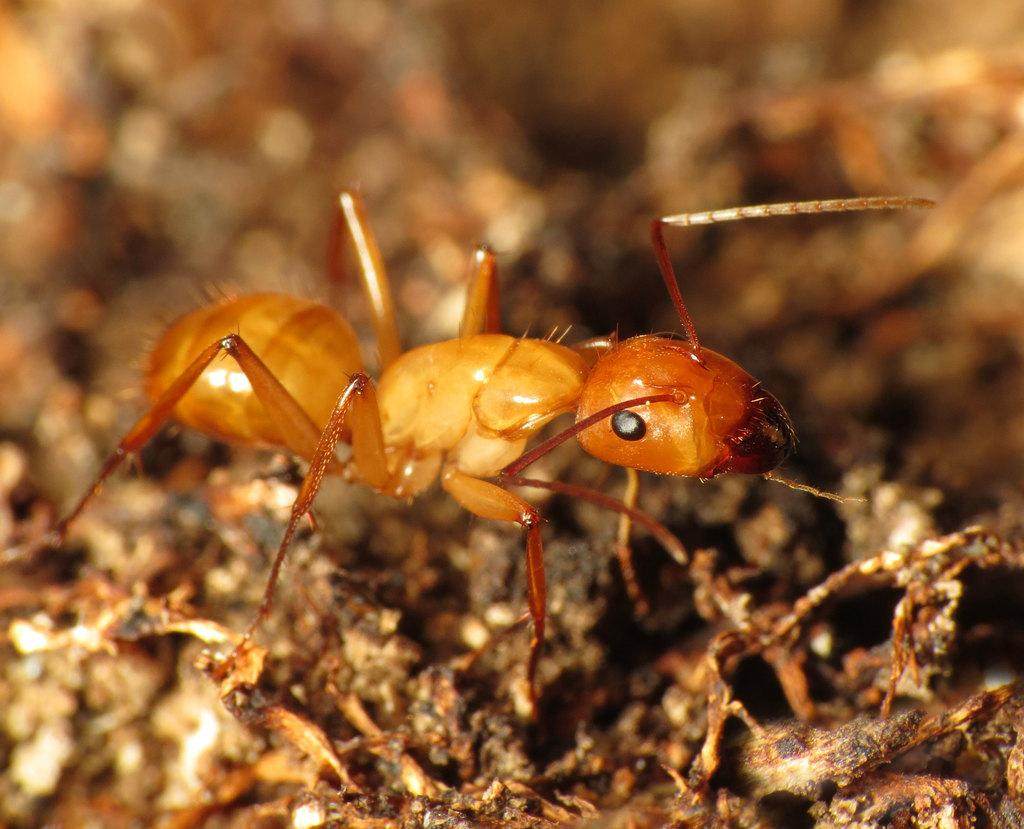What is the main subject of the image? The main subject of the image is an ant. Can you describe the color of the ant? The ant is pale brown in color. How would you describe the background of the image? The background of the image is blurred. What type of education does the ant have in the image? There is no indication in the image that the ant has any education, as ants do not receive formal education. 